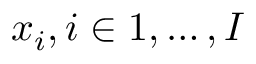<formula> <loc_0><loc_0><loc_500><loc_500>x _ { i } , i \in { 1 , \dots , I }</formula> 